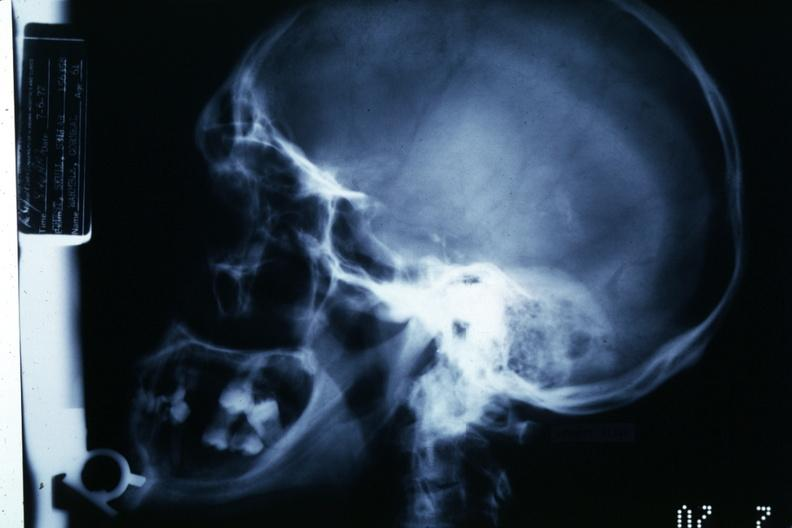s bone, calvarium present?
Answer the question using a single word or phrase. Yes 